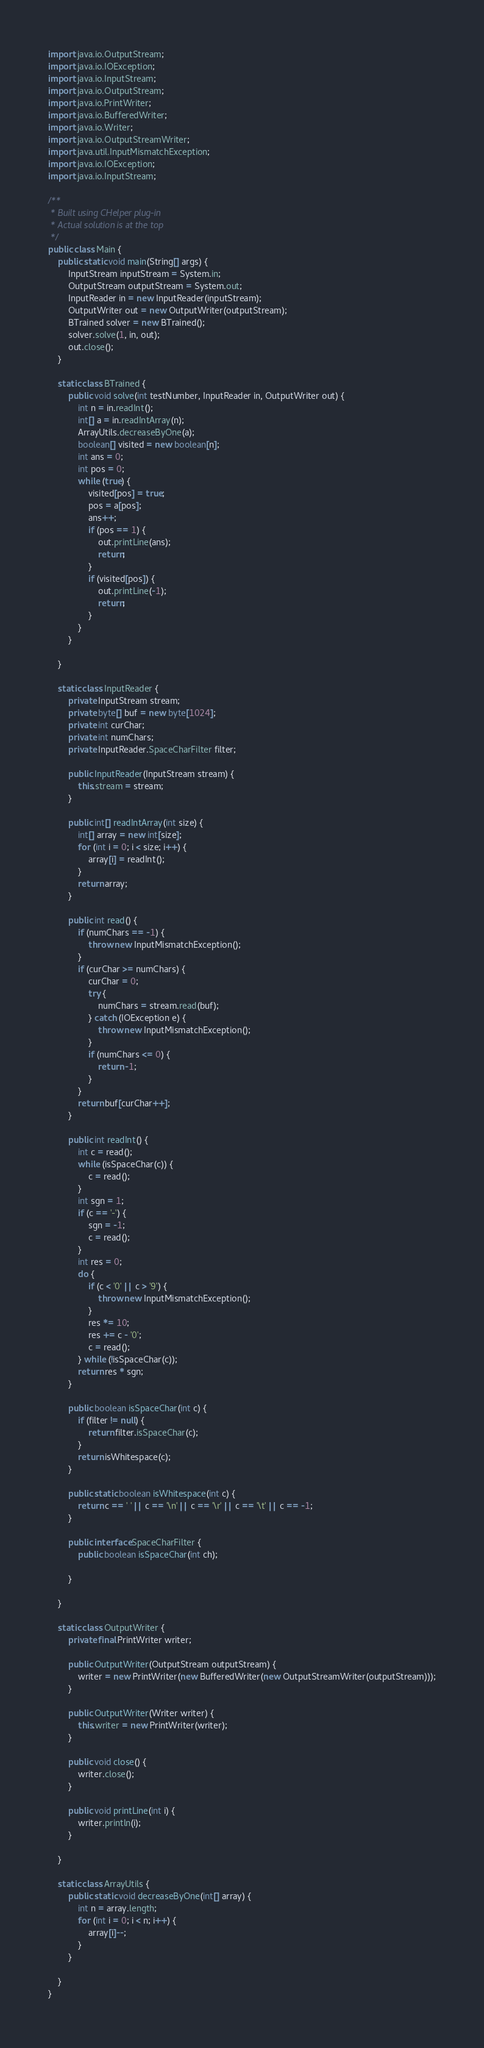Convert code to text. <code><loc_0><loc_0><loc_500><loc_500><_Java_>import java.io.OutputStream;
import java.io.IOException;
import java.io.InputStream;
import java.io.OutputStream;
import java.io.PrintWriter;
import java.io.BufferedWriter;
import java.io.Writer;
import java.io.OutputStreamWriter;
import java.util.InputMismatchException;
import java.io.IOException;
import java.io.InputStream;

/**
 * Built using CHelper plug-in
 * Actual solution is at the top
 */
public class Main {
    public static void main(String[] args) {
        InputStream inputStream = System.in;
        OutputStream outputStream = System.out;
        InputReader in = new InputReader(inputStream);
        OutputWriter out = new OutputWriter(outputStream);
        BTrained solver = new BTrained();
        solver.solve(1, in, out);
        out.close();
    }

    static class BTrained {
        public void solve(int testNumber, InputReader in, OutputWriter out) {
            int n = in.readInt();
            int[] a = in.readIntArray(n);
            ArrayUtils.decreaseByOne(a);
            boolean[] visited = new boolean[n];
            int ans = 0;
            int pos = 0;
            while (true) {
                visited[pos] = true;
                pos = a[pos];
                ans++;
                if (pos == 1) {
                    out.printLine(ans);
                    return;
                }
                if (visited[pos]) {
                    out.printLine(-1);
                    return;
                }
            }
        }

    }

    static class InputReader {
        private InputStream stream;
        private byte[] buf = new byte[1024];
        private int curChar;
        private int numChars;
        private InputReader.SpaceCharFilter filter;

        public InputReader(InputStream stream) {
            this.stream = stream;
        }

        public int[] readIntArray(int size) {
            int[] array = new int[size];
            for (int i = 0; i < size; i++) {
                array[i] = readInt();
            }
            return array;
        }

        public int read() {
            if (numChars == -1) {
                throw new InputMismatchException();
            }
            if (curChar >= numChars) {
                curChar = 0;
                try {
                    numChars = stream.read(buf);
                } catch (IOException e) {
                    throw new InputMismatchException();
                }
                if (numChars <= 0) {
                    return -1;
                }
            }
            return buf[curChar++];
        }

        public int readInt() {
            int c = read();
            while (isSpaceChar(c)) {
                c = read();
            }
            int sgn = 1;
            if (c == '-') {
                sgn = -1;
                c = read();
            }
            int res = 0;
            do {
                if (c < '0' || c > '9') {
                    throw new InputMismatchException();
                }
                res *= 10;
                res += c - '0';
                c = read();
            } while (!isSpaceChar(c));
            return res * sgn;
        }

        public boolean isSpaceChar(int c) {
            if (filter != null) {
                return filter.isSpaceChar(c);
            }
            return isWhitespace(c);
        }

        public static boolean isWhitespace(int c) {
            return c == ' ' || c == '\n' || c == '\r' || c == '\t' || c == -1;
        }

        public interface SpaceCharFilter {
            public boolean isSpaceChar(int ch);

        }

    }

    static class OutputWriter {
        private final PrintWriter writer;

        public OutputWriter(OutputStream outputStream) {
            writer = new PrintWriter(new BufferedWriter(new OutputStreamWriter(outputStream)));
        }

        public OutputWriter(Writer writer) {
            this.writer = new PrintWriter(writer);
        }

        public void close() {
            writer.close();
        }

        public void printLine(int i) {
            writer.println(i);
        }

    }

    static class ArrayUtils {
        public static void decreaseByOne(int[] array) {
            int n = array.length;
            for (int i = 0; i < n; i++) {
                array[i]--;
            }
        }

    }
}

</code> 